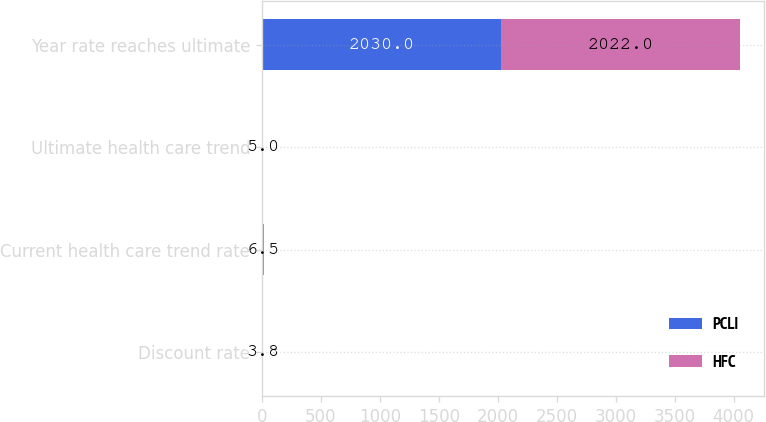Convert chart. <chart><loc_0><loc_0><loc_500><loc_500><stacked_bar_chart><ecel><fcel>Discount rate<fcel>Current health care trend rate<fcel>Ultimate health care trend<fcel>Year rate reaches ultimate<nl><fcel>PCLI<fcel>3.75<fcel>7<fcel>5<fcel>2030<nl><fcel>HFC<fcel>3.8<fcel>6.5<fcel>5<fcel>2022<nl></chart> 